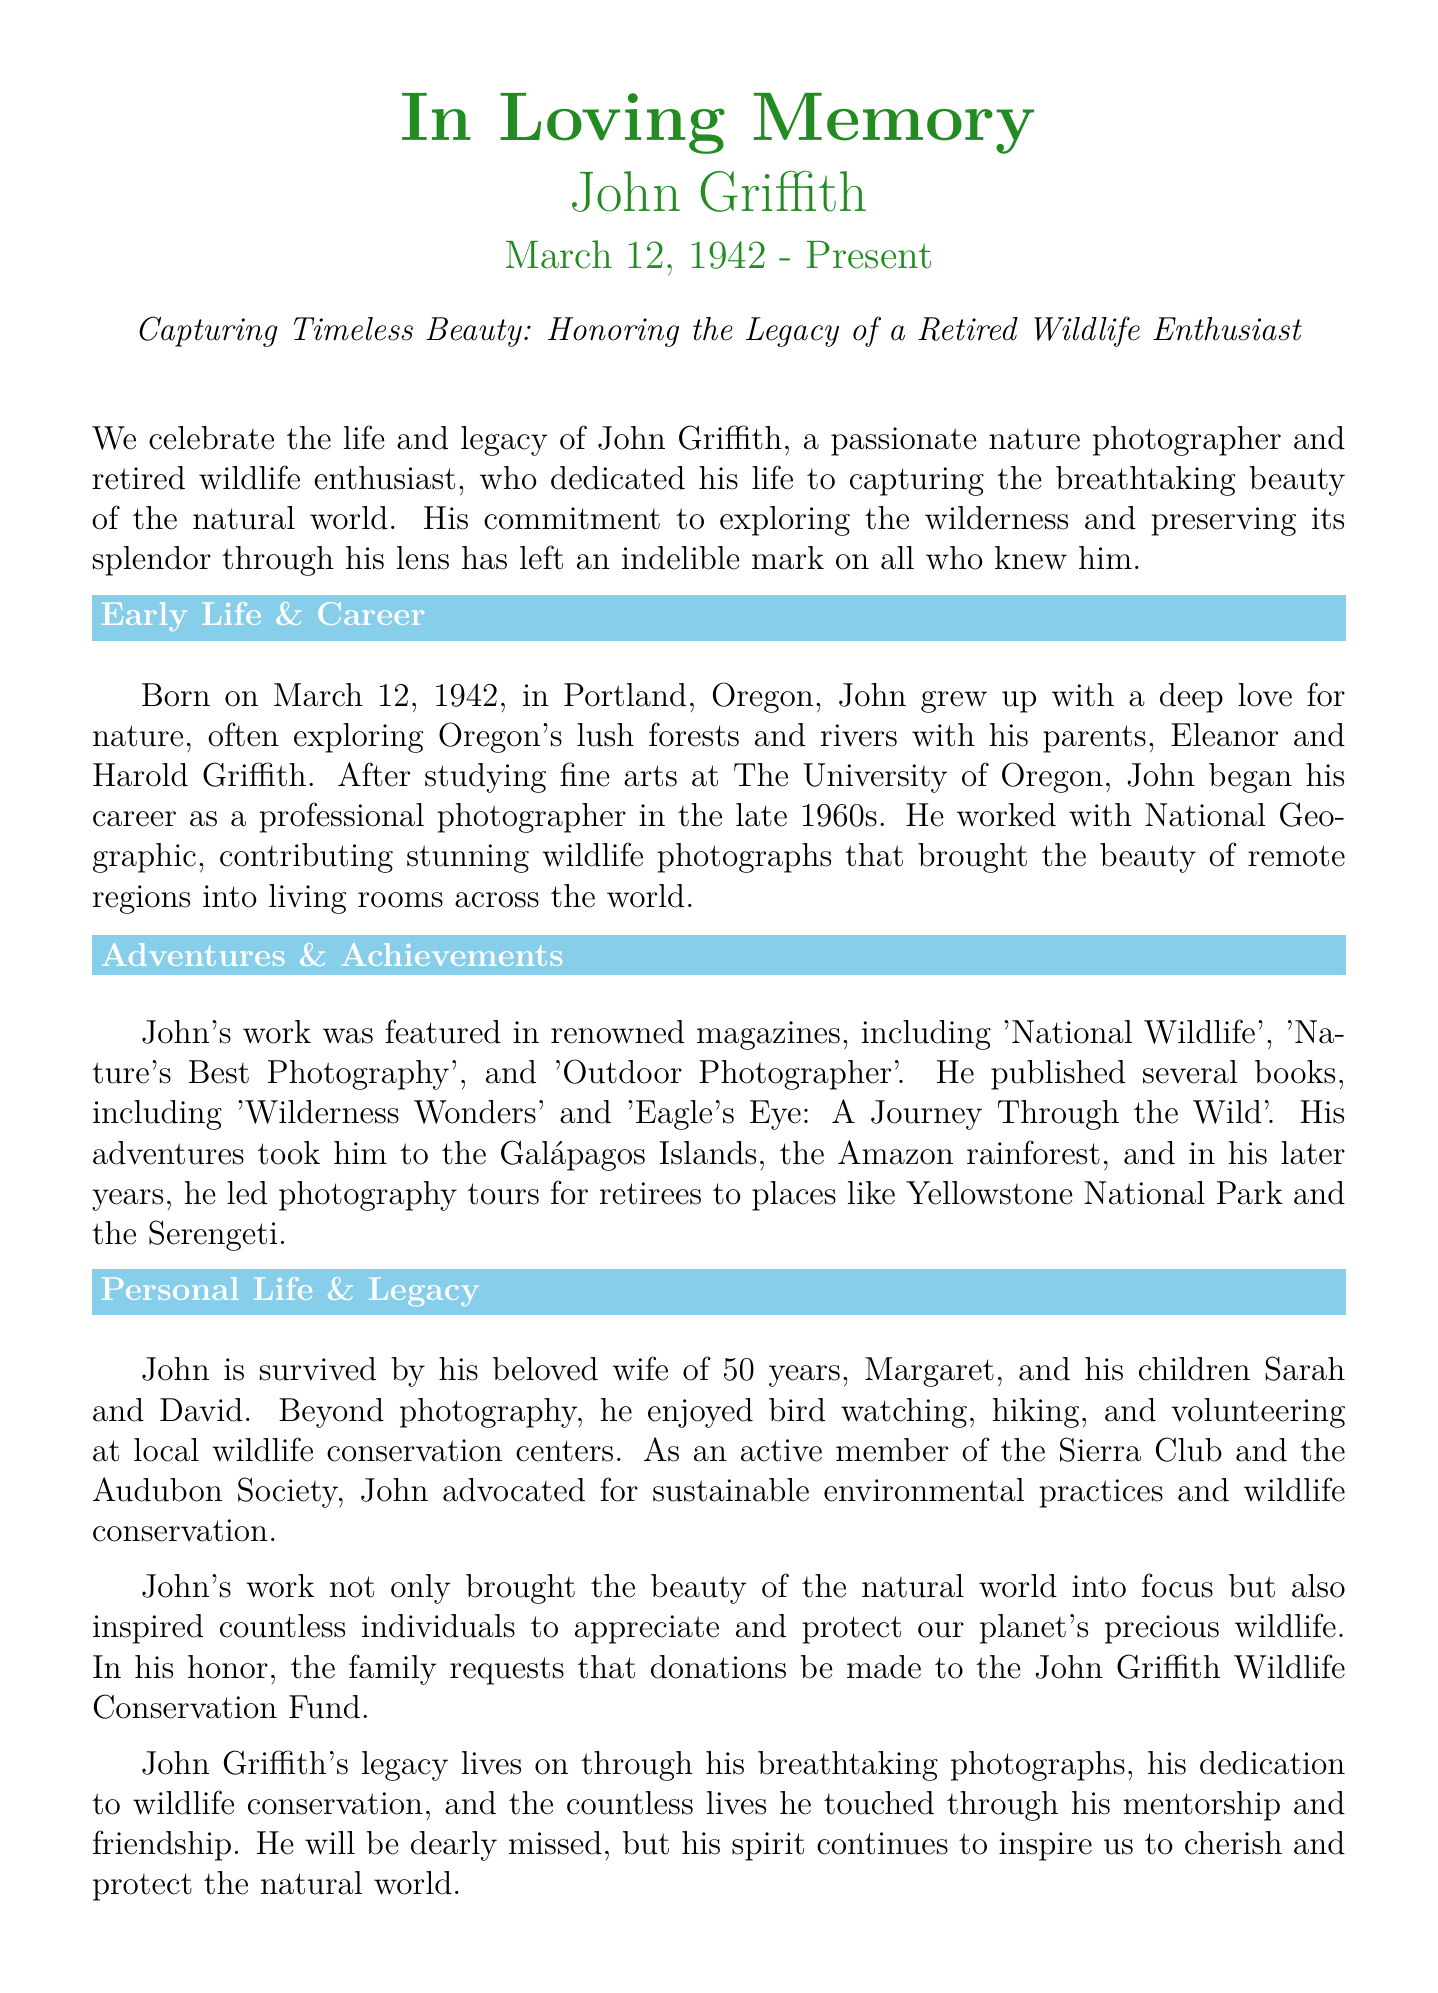What was John Griffith's birth date? John Griffith was born on March 12, 1942, as stated in the document.
Answer: March 12, 1942 What was the title of one of John Griffith's published books? The document lists 'Wilderness Wonders' and 'Eagle's Eye: A Journey Through the Wild' as his published works.
Answer: Wilderness Wonders Which organization did John advocate for sustainable environmental practices? John was an active member of the Sierra Club and the Audubon Society, as mentioned in the document.
Answer: Sierra Club What type of photography did John Griffith specialize in? The document describes him as a nature photographer and wildlife photographer throughout his career.
Answer: Nature photography How many years was John married to Margaret? It is stated that John was married to Margaret for 50 years.
Answer: 50 years What was one of John Griffith's notable contributions to magazines? He contributed stunning wildlife photographs to National Geographic, as stated in the document.
Answer: National Geographic What was the name of the fund established in John Griffith's honor? The family requests donations to the John Griffith Wildlife Conservation Fund as a way to honor him.
Answer: John Griffith Wildlife Conservation Fund 